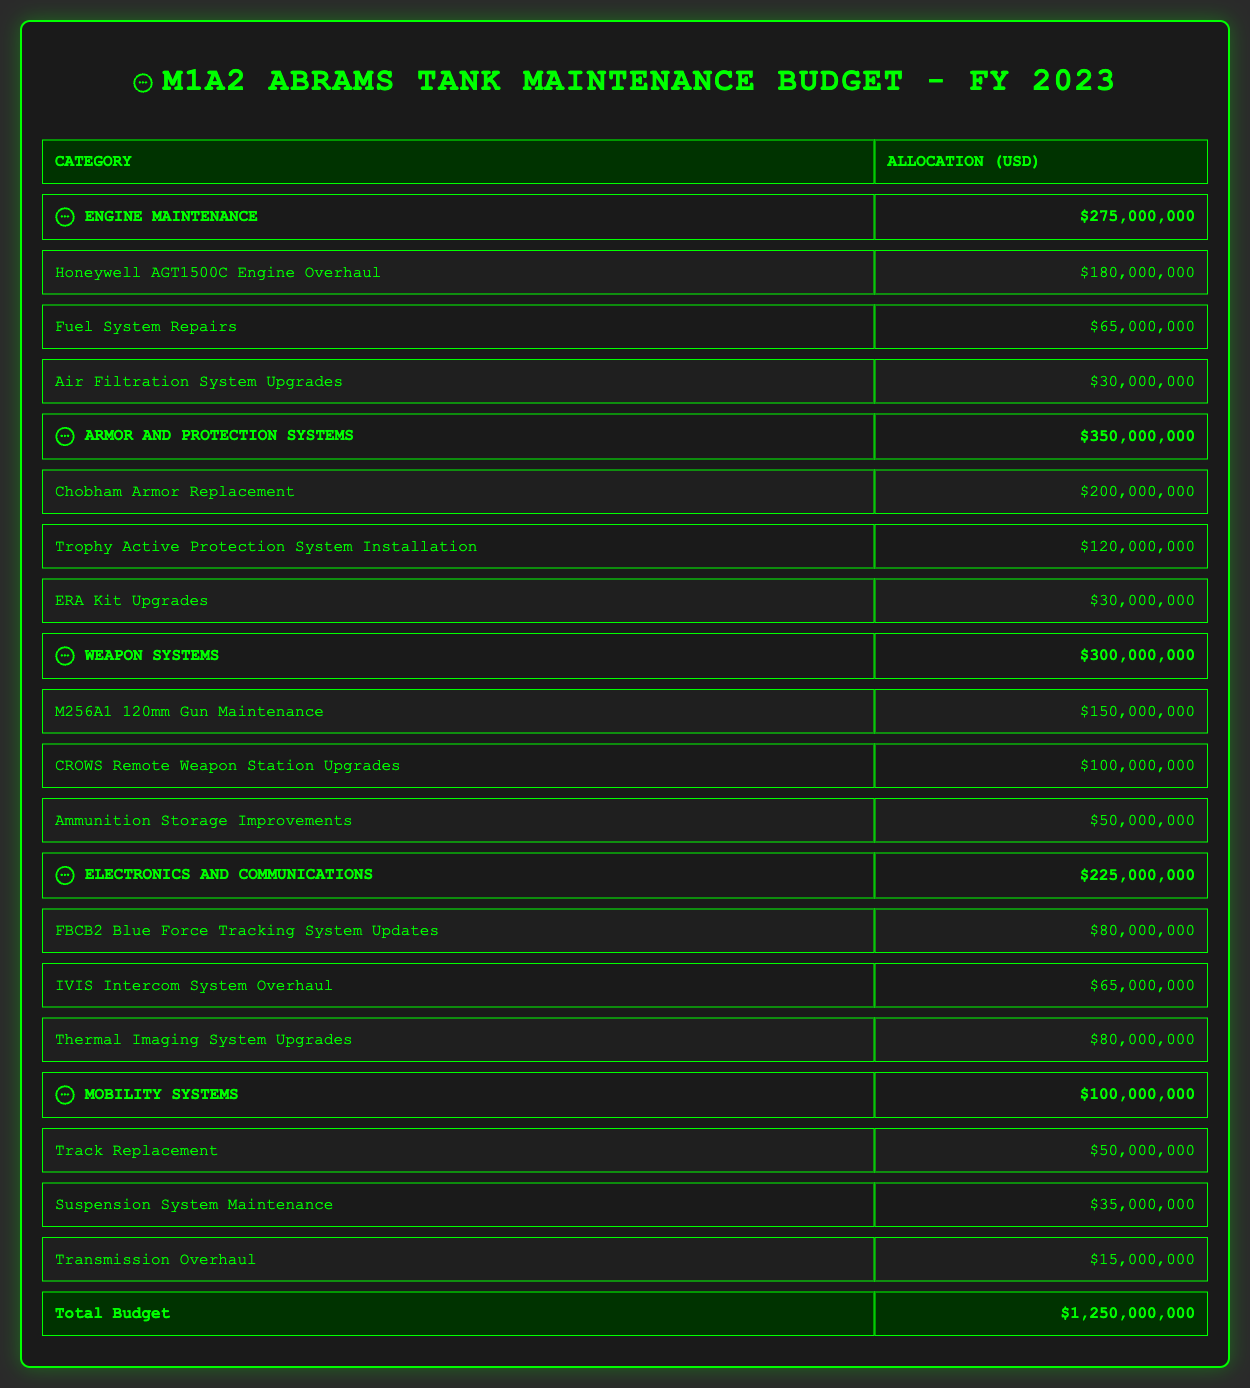What is the total budget allocation for Engine Maintenance? The category "Engine Maintenance" has an allocation of 275,000,000 USD as directly stated in the table.
Answer: 275,000,000 USD How much is allocated for the Chobham Armor Replacement? The sub-category "Chobham Armor Replacement" under "Armor and Protection Systems" shows an allocation of 200,000,000 USD.
Answer: 200,000,000 USD What is the combined total allocation for Weapon Systems and Electronics and Communications? The allocation for "Weapon Systems" is 300,000,000 USD and for "Electronics and Communications" it is 225,000,000 USD. Adding these two (300,000,000 + 225,000,000) gives us 525,000,000 USD.
Answer: 525,000,000 USD Is the budget for Fuel System Repairs greater than that for ERA Kit Upgrades? The budget for "Fuel System Repairs" is 65,000,000 USD and for "ERA Kit Upgrades" is 30,000,000 USD. Since 65,000,000 is greater than 30,000,000, the statement is true.
Answer: Yes What percentage of the total budget is allocated to Armor and Protection Systems? The total budget is 1,250,000,000 USD, with Armor and Protection Systems allocated 350,000,000 USD. To find the percentage, calculate (350,000,000 / 1,250,000,000) * 100, which equals 28%.
Answer: 28% Which category has the highest allocation, and how much is it? By reviewing the allocations: Engine Maintenance (275,000,000), Armor and Protection Systems (350,000,000), Weapon Systems (300,000,000), Electronics and Communications (225,000,000), Mobility Systems (100,000,000), "Armor and Protection Systems" has the highest allocation of 350,000,000 USD.
Answer: Armor and Protection Systems, 350,000,000 USD Are the total allocations for Mobility Systems and Engine Maintenance greater than 400,000,000 USD together? The allocation for "Mobility Systems" is 100,000,000 USD and "Engine Maintenance" is 275,000,000 USD. Summing these gives (100,000,000 + 275,000,000) = 375,000,000 USD, which is less than 400,000,000 USD.
Answer: No What is the total amount allocated for sub-categories under Weapon Systems? Adding the amounts for the three sub-categories: M256A1 120mm Gun Maintenance (150,000,000), CROWS Remote Weapon Station Upgrades (100,000,000), and Ammunition Storage Improvements (50,000,000) gives us (150,000,000 + 100,000,000 + 50,000,000) = 300,000,000 USD.
Answer: 300,000,000 USD 